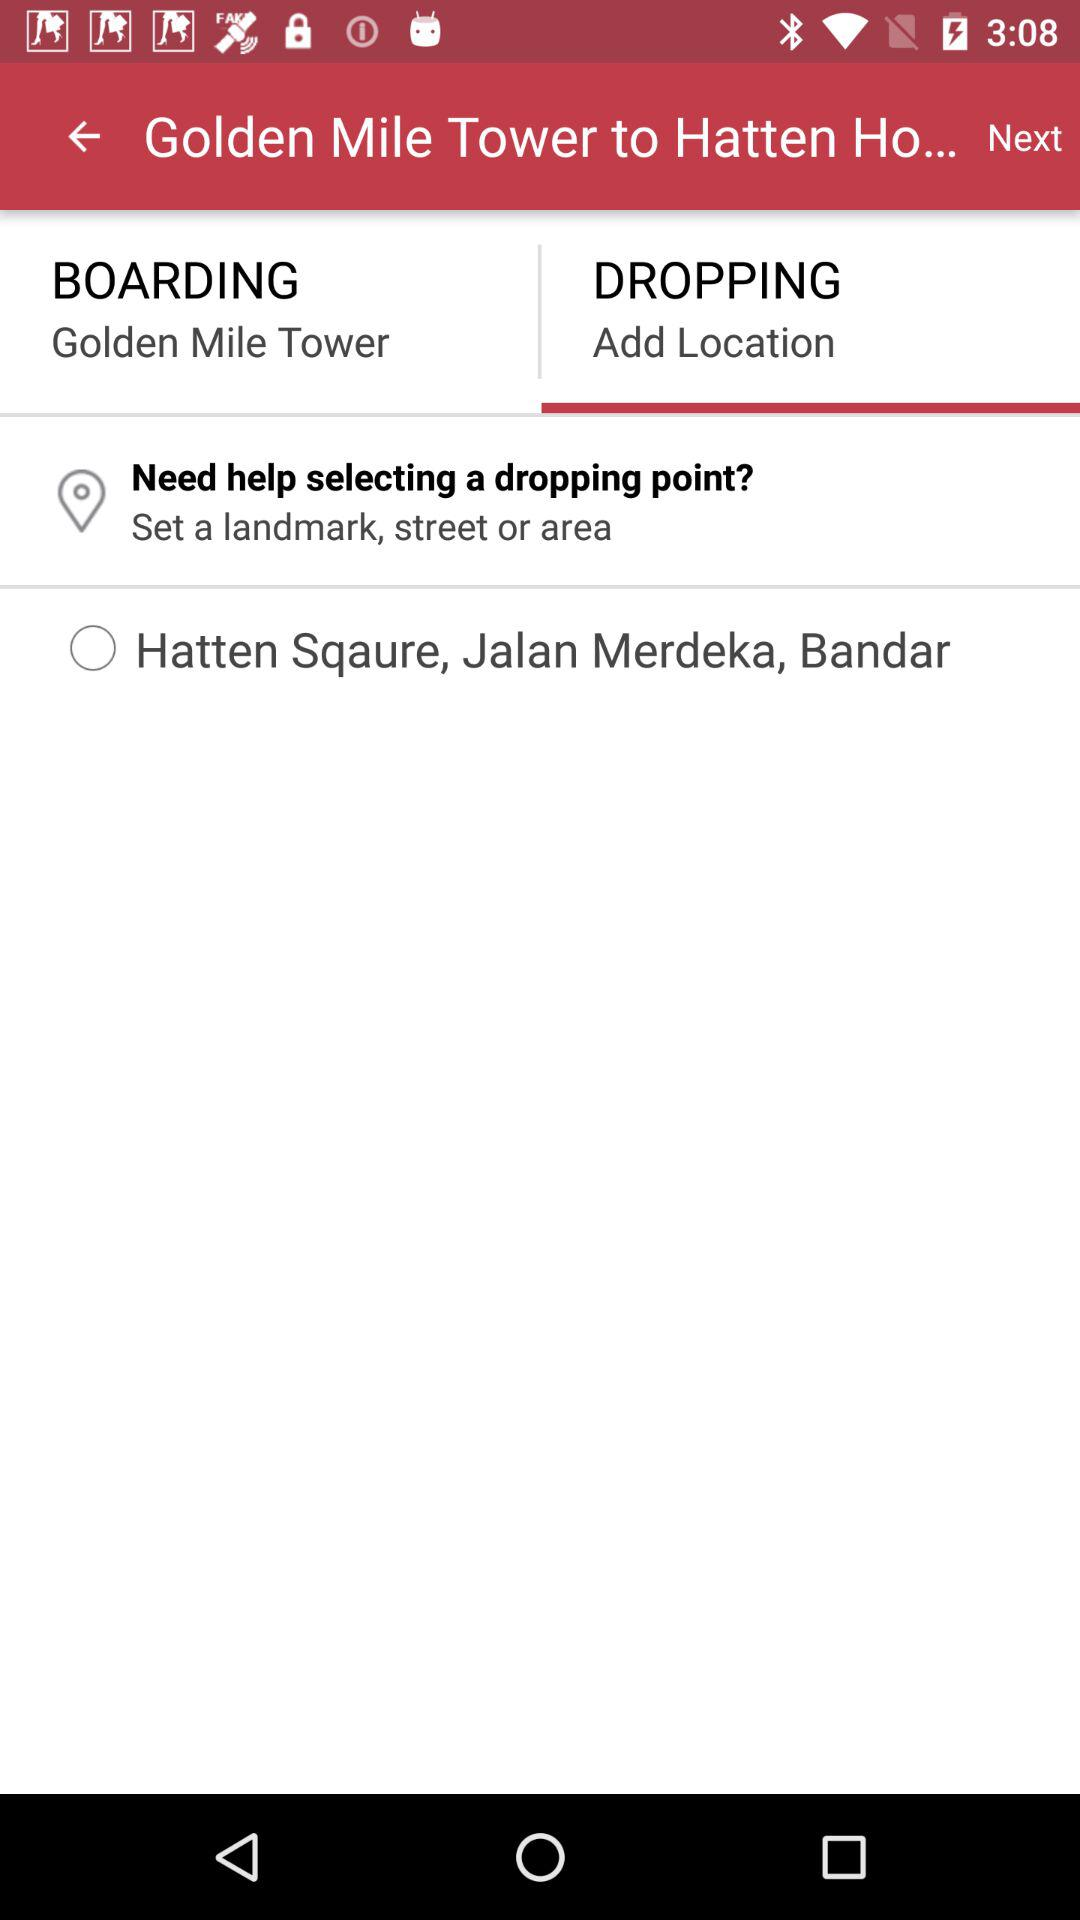What is the drop location? The drop location is "Hatten Square, Jalan Merdeka, Bandar". 